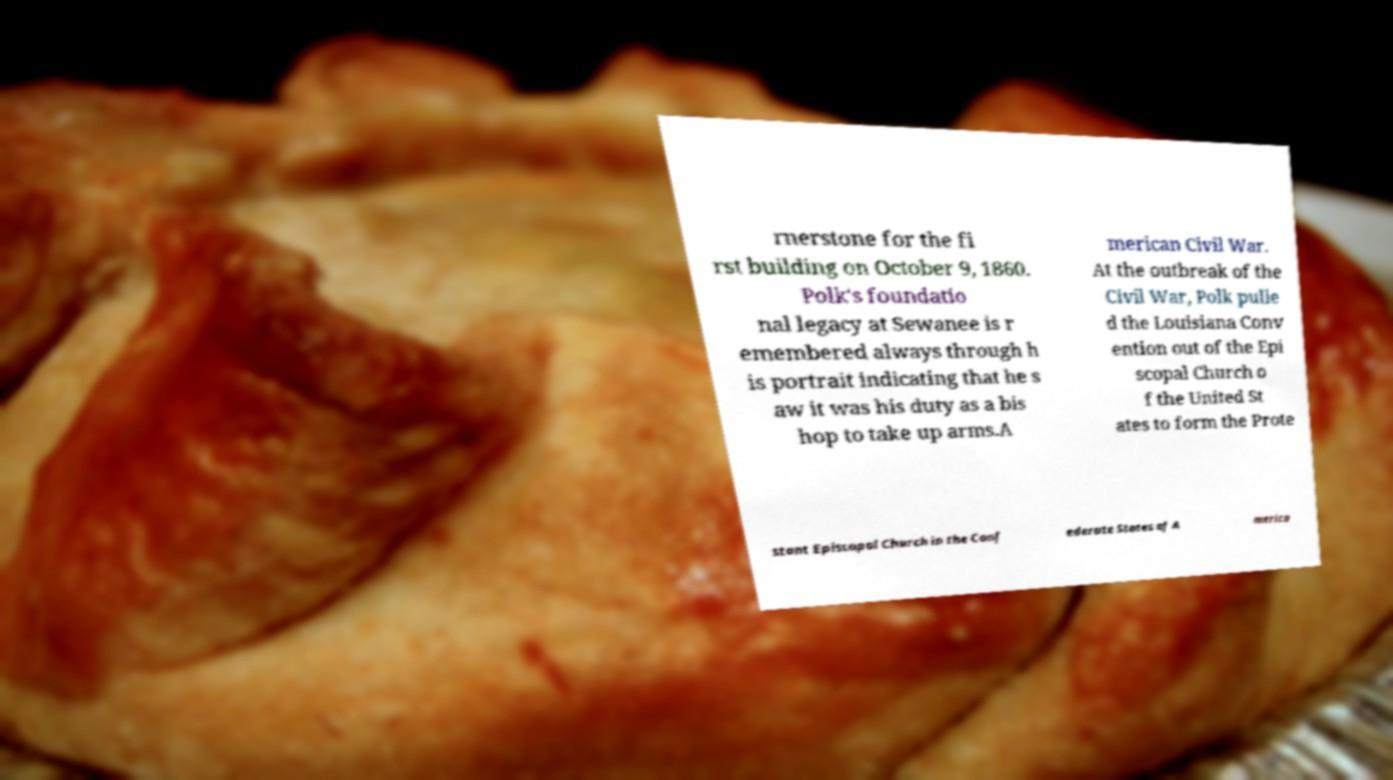Could you assist in decoding the text presented in this image and type it out clearly? rnerstone for the fi rst building on October 9, 1860. Polk's foundatio nal legacy at Sewanee is r emembered always through h is portrait indicating that he s aw it was his duty as a bis hop to take up arms.A merican Civil War. At the outbreak of the Civil War, Polk pulle d the Louisiana Conv ention out of the Epi scopal Church o f the United St ates to form the Prote stant Episcopal Church in the Conf ederate States of A merica 